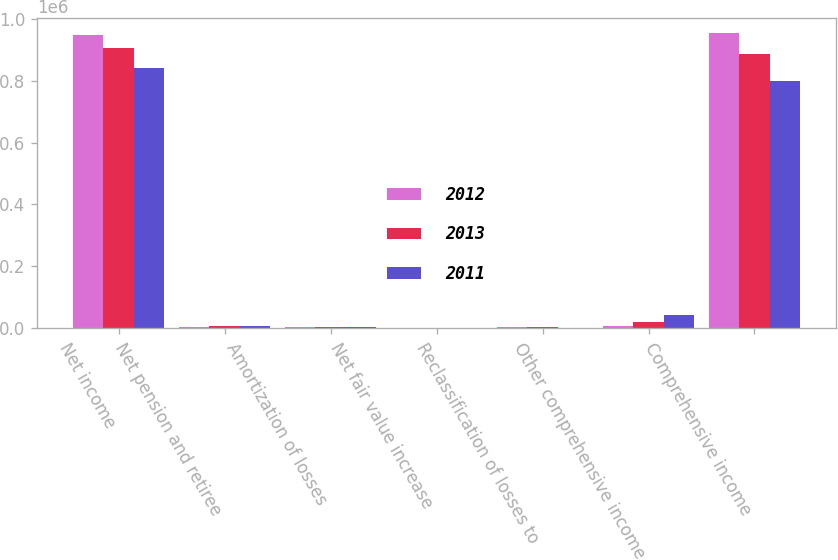<chart> <loc_0><loc_0><loc_500><loc_500><stacked_bar_chart><ecel><fcel>Net income<fcel>Net pension and retiree<fcel>Amortization of losses<fcel>Net fair value increase<fcel>Reclassification of losses to<fcel>Other comprehensive income<fcel>Comprehensive income<nl><fcel>2012<fcel>948234<fcel>1408<fcel>3306<fcel>176<fcel>1476<fcel>6378<fcel>954612<nl><fcel>2013<fcel>905229<fcel>7005<fcel>3694<fcel>196<fcel>3697<fcel>18618<fcel>886611<nl><fcel>2011<fcel>841172<fcel>6367<fcel>3162<fcel>93<fcel>648<fcel>40942<fcel>800230<nl></chart> 